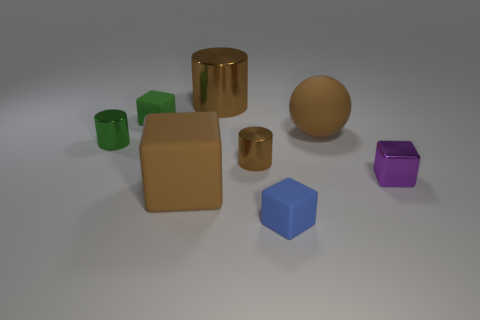Is there a big rubber object that has the same shape as the small blue rubber object?
Your answer should be compact. Yes. Does the big metallic thing have the same color as the matte sphere?
Make the answer very short. Yes. Is there a small purple block in front of the brown matte thing that is on the left side of the big cylinder?
Give a very brief answer. No. How many things are either cylinders in front of the small green metallic thing or objects that are to the left of the large brown cube?
Your answer should be very brief. 3. How many objects are either tiny brown shiny cylinders or matte cubes that are to the right of the large brown metal cylinder?
Offer a terse response. 2. What size is the brown matte cube that is on the left side of the shiny thing that is behind the small matte cube that is behind the big brown matte cube?
Your response must be concise. Large. There is a brown cylinder that is the same size as the brown sphere; what material is it?
Keep it short and to the point. Metal. Is there a metal thing that has the same size as the green rubber object?
Keep it short and to the point. Yes. Is the size of the brown thing on the right side of the blue matte object the same as the purple object?
Make the answer very short. No. There is a big brown object that is both left of the rubber sphere and in front of the green rubber cube; what shape is it?
Provide a short and direct response. Cube. 